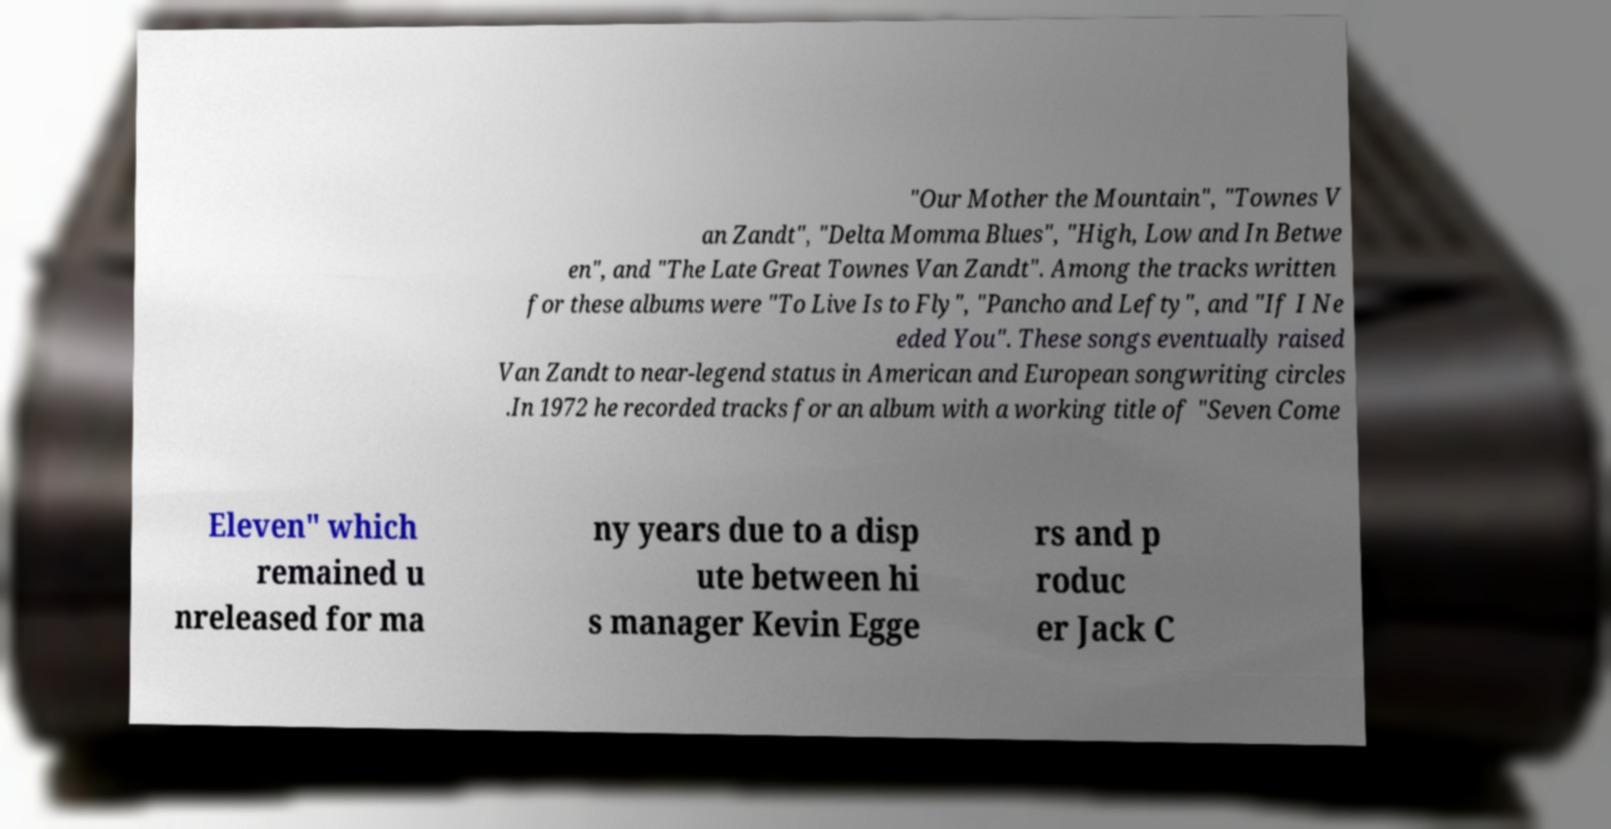Could you extract and type out the text from this image? "Our Mother the Mountain", "Townes V an Zandt", "Delta Momma Blues", "High, Low and In Betwe en", and "The Late Great Townes Van Zandt". Among the tracks written for these albums were "To Live Is to Fly", "Pancho and Lefty", and "If I Ne eded You". These songs eventually raised Van Zandt to near-legend status in American and European songwriting circles .In 1972 he recorded tracks for an album with a working title of "Seven Come Eleven" which remained u nreleased for ma ny years due to a disp ute between hi s manager Kevin Egge rs and p roduc er Jack C 